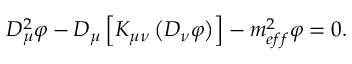<formula> <loc_0><loc_0><loc_500><loc_500>D _ { \mu } ^ { 2 } \varphi - D _ { \mu } \left [ K _ { \mu \nu } \left ( D _ { \nu } \varphi \right ) \right ] - m _ { e f f } ^ { 2 } \varphi = 0 .</formula> 